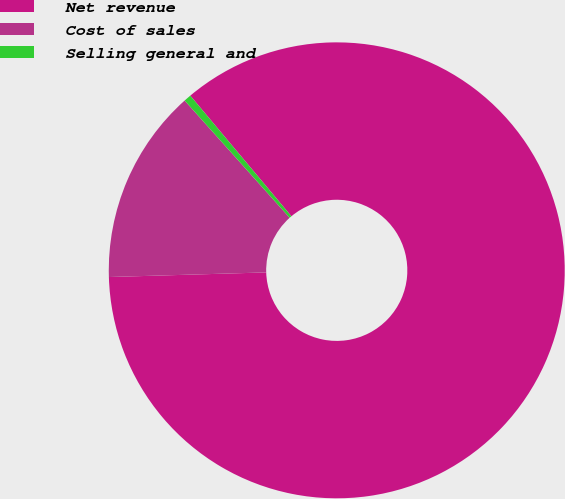Convert chart to OTSL. <chart><loc_0><loc_0><loc_500><loc_500><pie_chart><fcel>Net revenue<fcel>Cost of sales<fcel>Selling general and<nl><fcel>85.63%<fcel>13.84%<fcel>0.52%<nl></chart> 